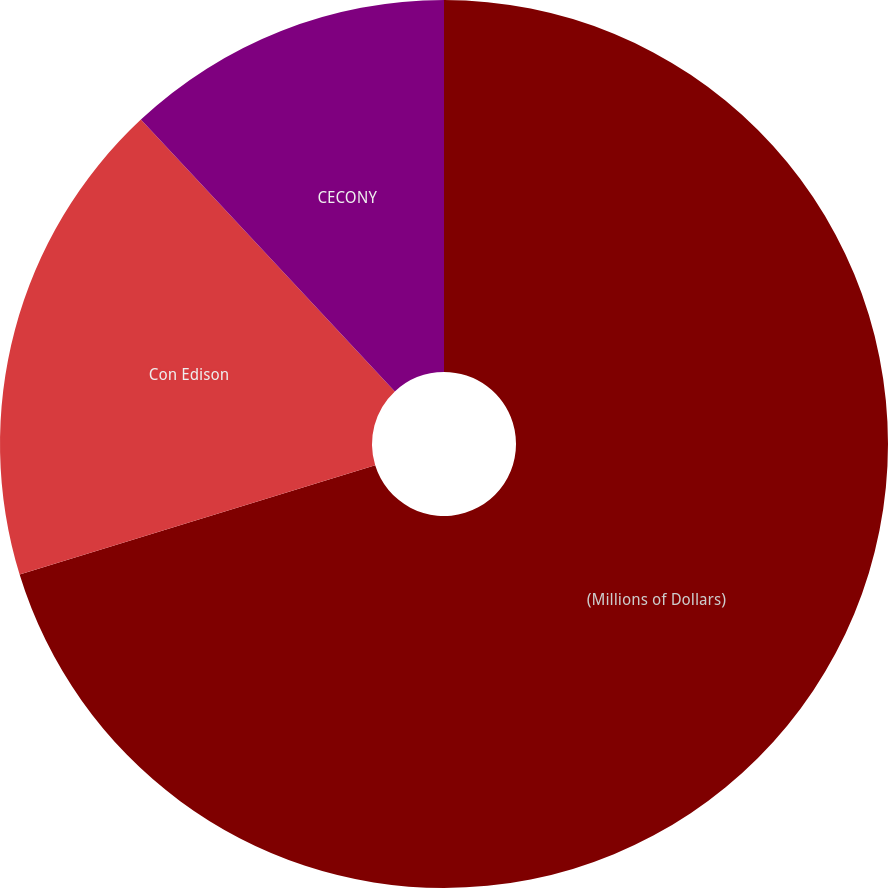<chart> <loc_0><loc_0><loc_500><loc_500><pie_chart><fcel>(Millions of Dollars)<fcel>Con Edison<fcel>CECONY<nl><fcel>70.25%<fcel>17.79%<fcel>11.96%<nl></chart> 